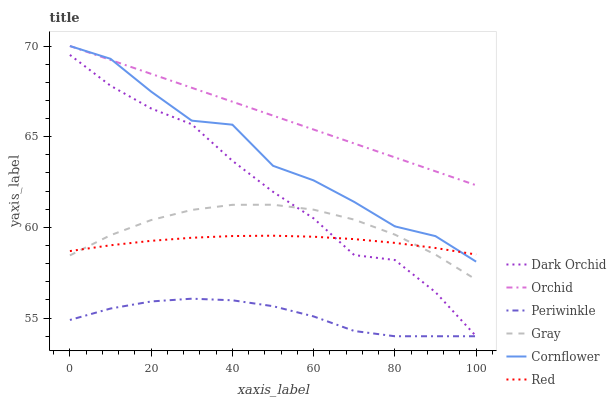Does Periwinkle have the minimum area under the curve?
Answer yes or no. Yes. Does Orchid have the maximum area under the curve?
Answer yes or no. Yes. Does Cornflower have the minimum area under the curve?
Answer yes or no. No. Does Cornflower have the maximum area under the curve?
Answer yes or no. No. Is Orchid the smoothest?
Answer yes or no. Yes. Is Cornflower the roughest?
Answer yes or no. Yes. Is Dark Orchid the smoothest?
Answer yes or no. No. Is Dark Orchid the roughest?
Answer yes or no. No. Does Cornflower have the lowest value?
Answer yes or no. No. Does Orchid have the highest value?
Answer yes or no. Yes. Does Dark Orchid have the highest value?
Answer yes or no. No. Is Red less than Orchid?
Answer yes or no. Yes. Is Gray greater than Periwinkle?
Answer yes or no. Yes. Does Periwinkle intersect Dark Orchid?
Answer yes or no. Yes. Is Periwinkle less than Dark Orchid?
Answer yes or no. No. Is Periwinkle greater than Dark Orchid?
Answer yes or no. No. Does Red intersect Orchid?
Answer yes or no. No. 